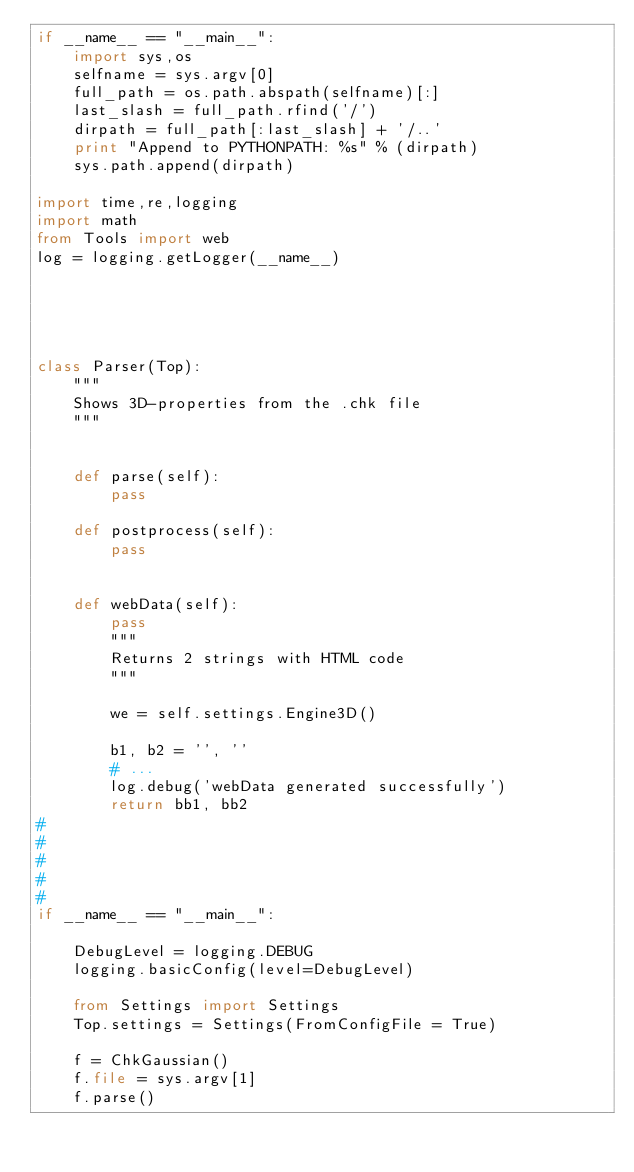Convert code to text. <code><loc_0><loc_0><loc_500><loc_500><_Python_>if __name__ == "__main__":
    import sys,os
    selfname = sys.argv[0]
    full_path = os.path.abspath(selfname)[:]
    last_slash = full_path.rfind('/')
    dirpath = full_path[:last_slash] + '/..'
    print "Append to PYTHONPATH: %s" % (dirpath)
    sys.path.append(dirpath)

import time,re,logging
import math
from Tools import web
log = logging.getLogger(__name__)





class Parser(Top):
    """
    Shows 3D-properties from the .chk file
    """


    def parse(self):
		pass

    def postprocess(self):
		pass


    def webData(self):
		pass
        """
        Returns 2 strings with HTML code
        """

        we = self.settings.Engine3D()

        b1, b2 = '', ''
		# ...
        log.debug('webData generated successfully')
        return bb1, bb2
#
#
#
#
#
if __name__ == "__main__":

    DebugLevel = logging.DEBUG
    logging.basicConfig(level=DebugLevel)

    from Settings import Settings
    Top.settings = Settings(FromConfigFile = True)

    f = ChkGaussian()
    f.file = sys.argv[1]
    f.parse()
</code> 